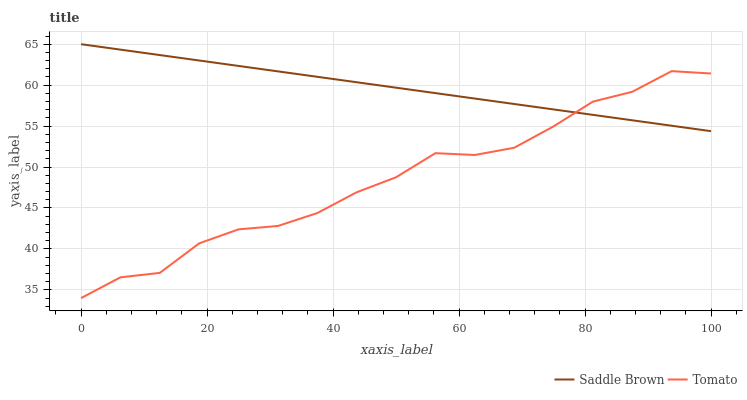Does Saddle Brown have the minimum area under the curve?
Answer yes or no. No. Is Saddle Brown the roughest?
Answer yes or no. No. Does Saddle Brown have the lowest value?
Answer yes or no. No. 